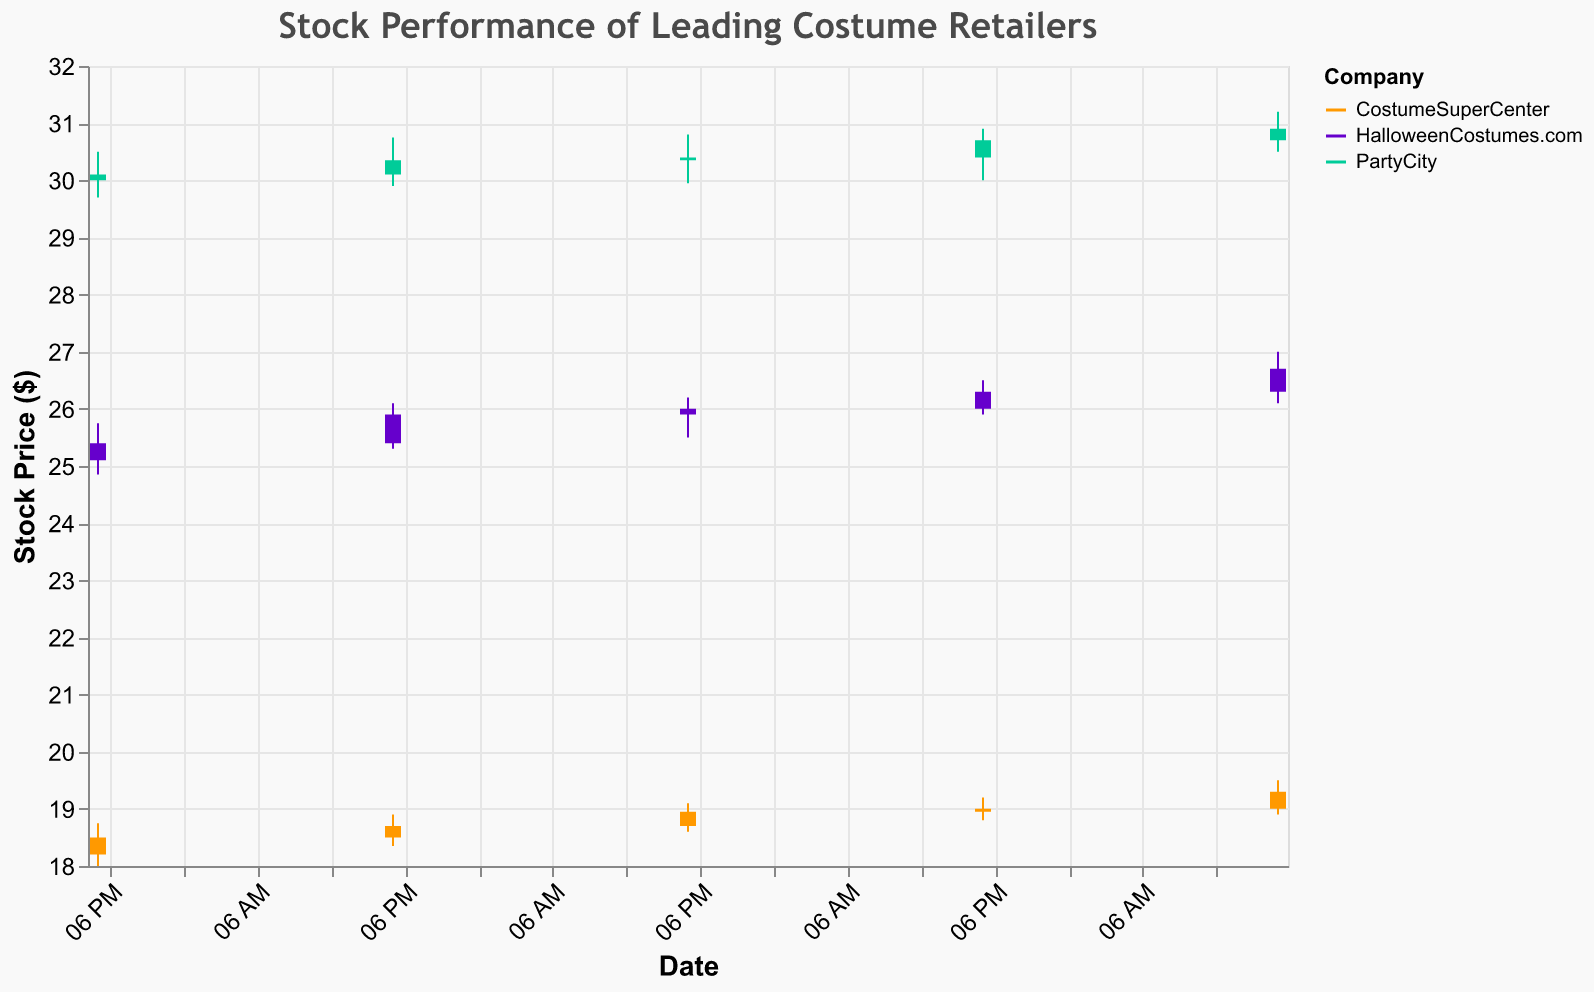How many companies are displayed in the figure? The figure uses different colors to represent each company. By counting the distinct colors and their legends, we can determine the number of companies displayed. There are three companies: "HalloweenCostumes.com," "CostumeSuperCenter," and "PartyCity."
Answer: 3 Which company had the highest closing price on September 5, 2023? To find this, locate the closing prices for each company on September 5, 2023. "PartyCity" closed at 30.90, "HalloweenCostumes.com" at 26.70, and "CostumeSuperCenter" at 19.30. The highest closing price is 30.90 from "PartyCity."
Answer: PartyCity What's the opening price of HalloweenCostumes.com on September 3, 2023? Locate the data for HalloweenCostumes.com on September 3, 2023. The entry shows that the stock opened at 25.90 on that day.
Answer: 25.90 What is the total trading volume for PartyCity over the displayed period? Sum up the trading volumes for PartyCity from September 1 to September 5, 2023. The volumes are 650,000, 660,000, 670,000, 680,000, and 690,000. Adding these gives a total of 3,350,000.
Answer: 3,350,000 What is the average high price of CostumeSuperCenter from September 1 to September 5, 2023? Add up the high prices from September 1 to September 5 (18.75, 18.90, 19.10, 19.20, 19.50) and divide by the number of days (5). The sum is 95.45, and dividing by 5 gives 19.09.
Answer: 19.09 